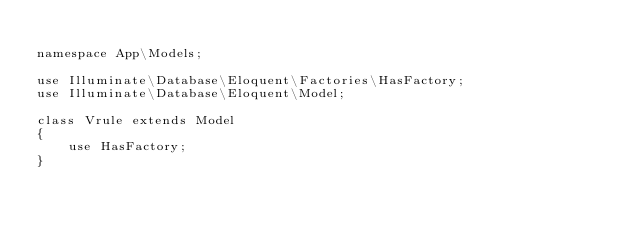<code> <loc_0><loc_0><loc_500><loc_500><_PHP_>
namespace App\Models;

use Illuminate\Database\Eloquent\Factories\HasFactory;
use Illuminate\Database\Eloquent\Model;

class Vrule extends Model
{
    use HasFactory;
}
</code> 